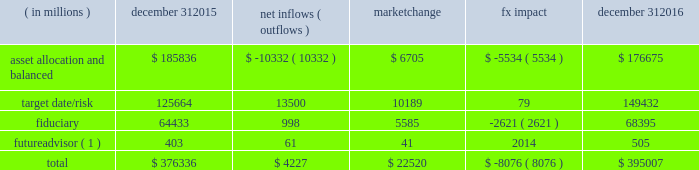Long-term product offerings include active and index strategies .
Our active strategies seek to earn attractive returns in excess of a market benchmark or performance hurdle while maintaining an appropriate risk profile .
We offer two types of active strategies : those that rely primarily on fundamental research and those that utilize primarily quantitative models to drive portfolio construction .
In contrast , index strategies seek to closely track the returns of a corresponding index , generally by investing in substantially the same underlying securities within the index or in a subset of those securities selected to approximate a similar risk and return profile of the index .
Index strategies include both our non-etf index products and ishares etfs .
Although many clients use both active and index strategies , the application of these strategies may differ .
For example , clients may use index products to gain exposure to a market or asset class , or may use a combination of index strategies to target active returns .
In addition , institutional non-etf index assignments tend to be very large ( multi-billion dollars ) and typically reflect low fee rates .
This has the potential to exaggerate the significance of net flows in institutional index products on blackrock 2019s revenues and earnings .
Equity year-end 2016 equity aum totaled $ 2.657 trillion , reflecting net inflows of $ 51.4 billion .
Net inflows included $ 74.9 billion into ishares , driven by net inflows into the core ranges and broad developed and emerging market equities .
Ishares net inflows were partially offset by active and non-etf index net outflows of $ 20.2 billion and $ 3.3 billion , respectively .
Blackrock 2019s effective fee rates fluctuate due to changes in aum mix .
Approximately half of blackrock 2019s equity aum is tied to international markets , including emerging markets , which tend to have higher fee rates than u.s .
Equity strategies .
Accordingly , fluctuations in international equity markets , which may not consistently move in tandem with u.s .
Markets , have a greater impact on blackrock 2019s effective equity fee rates and revenues .
Fixed income fixed income aum ended 2016 at $ 1.572 trillion , reflecting net inflows of $ 120.0 billion .
In 2016 , active net inflows of $ 16.6 billion were diversified across fixed income offerings , and included strong inflows from insurance clients .
Fixed income ishares net inflows of $ 59.9 billion were led by flows into the core ranges , emerging market , high yield and corporate bond funds .
Non-etf index net inflows of $ 43.4 billion were driven by demand for liability-driven investment solutions .
Multi-asset blackrock 2019s multi-asset team manages a variety of balanced funds and bespoke mandates for a diversified client base that leverages our broad investment expertise in global equities , bonds , currencies and commodities , and our extensive risk management capabilities .
Investment solutions might include a combination of long-only portfolios and alternative investments as well as tactical asset allocation overlays .
Component changes in multi-asset aum for 2016 are presented below .
( in millions ) december 31 , net inflows ( outflows ) market change impact december 31 .
( 1 ) the futureadvisor amount does not include aum that was held in ishares holdings .
Multi-asset net inflows reflected ongoing institutional demand for our solutions-based advice with $ 13.2 billion of net inflows coming from institutional clients .
Defined contribution plans of institutional clients remained a significant driver of flows , and contributed $ 11.3 billion to institutional multi-asset net inflows in 2016 , primarily into target date and target risk product offerings .
Retail net outflows of $ 9.4 billion were primarily due to outflows from world allocation strategies .
The company 2019s multi-asset strategies include the following : 2022 asset allocation and balanced products represented 45% ( 45 % ) of multi-asset aum at year-end .
These strategies combine equity , fixed income and alternative components for investors seeking a tailored solution relative to a specific benchmark and within a risk budget .
In certain cases , these strategies seek to minimize downside risk through diversification , derivatives strategies and tactical asset allocation decisions .
Flagship products in this category include our global allocation and multi-asset income fund families .
2022 target date and target risk products grew 11% ( 11 % ) organically in 2016 , with net inflows of $ 13.5 billion .
Institutional investors represented 94% ( 94 % ) of target date and target risk aum , with defined contribution plans accounting for 88% ( 88 % ) of aum .
Flows were driven by defined contribution investments in our lifepath and lifepath retirement income ae offerings .
Lifepath products utilize a proprietary asset allocation model that seeks to balance risk and return over an investment horizon based on the investor 2019s expected retirement timing .
2022 fiduciary management services are complex mandates in which pension plan sponsors or endowments and foundations retain blackrock to assume responsibility for some or all aspects of plan management .
These customized services require strong partnership with the clients 2019 investment staff and trustees in order to tailor investment strategies to meet client-specific risk budgets and return objectives. .
What is the percentage change in total multi-asset aum during 2016? 
Computations: ((395007 - 376336) / 376336)
Answer: 0.04961. 